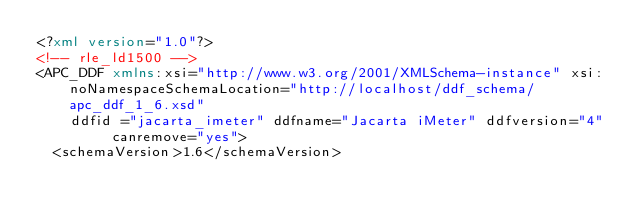Convert code to text. <code><loc_0><loc_0><loc_500><loc_500><_XML_><?xml version="1.0"?>
<!-- rle_ld1500 -->
<APC_DDF xmlns:xsi="http://www.w3.org/2001/XMLSchema-instance" xsi:noNamespaceSchemaLocation="http://localhost/ddf_schema/apc_ddf_1_6.xsd"
		ddfid ="jacarta_imeter" ddfname="Jacarta iMeter" ddfversion="4" canremove="yes">
	<schemaVersion>1.6</schemaVersion>
</code> 